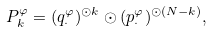<formula> <loc_0><loc_0><loc_500><loc_500>P ^ { \varphi } _ { k } = ( q _ { \cdot } ^ { \varphi } ) ^ { \odot k } \odot ( p _ { \cdot } ^ { \varphi } ) ^ { \odot ( N - k ) } ,</formula> 